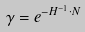Convert formula to latex. <formula><loc_0><loc_0><loc_500><loc_500>\gamma = e ^ { - H ^ { - 1 } \cdot N }</formula> 